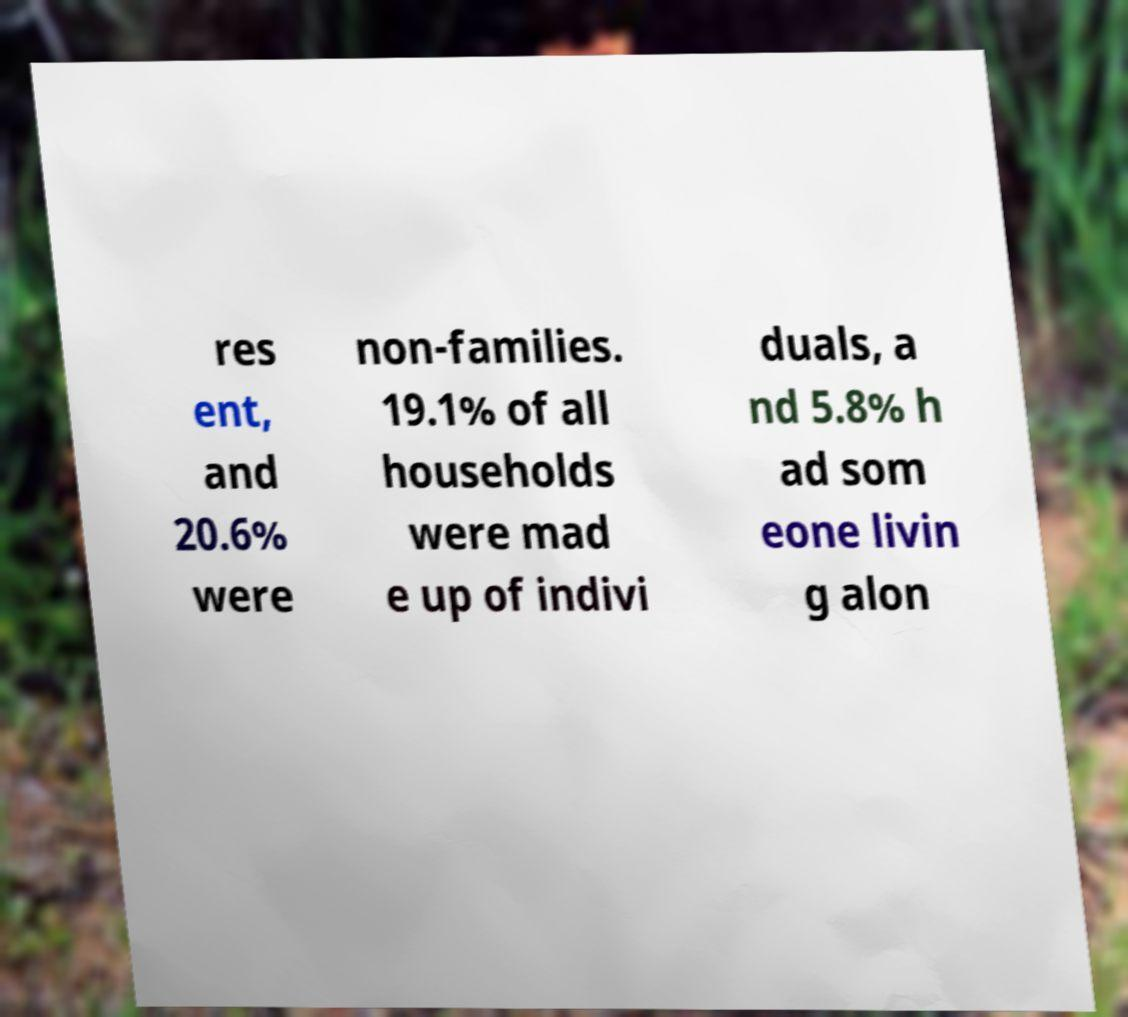Could you extract and type out the text from this image? res ent, and 20.6% were non-families. 19.1% of all households were mad e up of indivi duals, a nd 5.8% h ad som eone livin g alon 